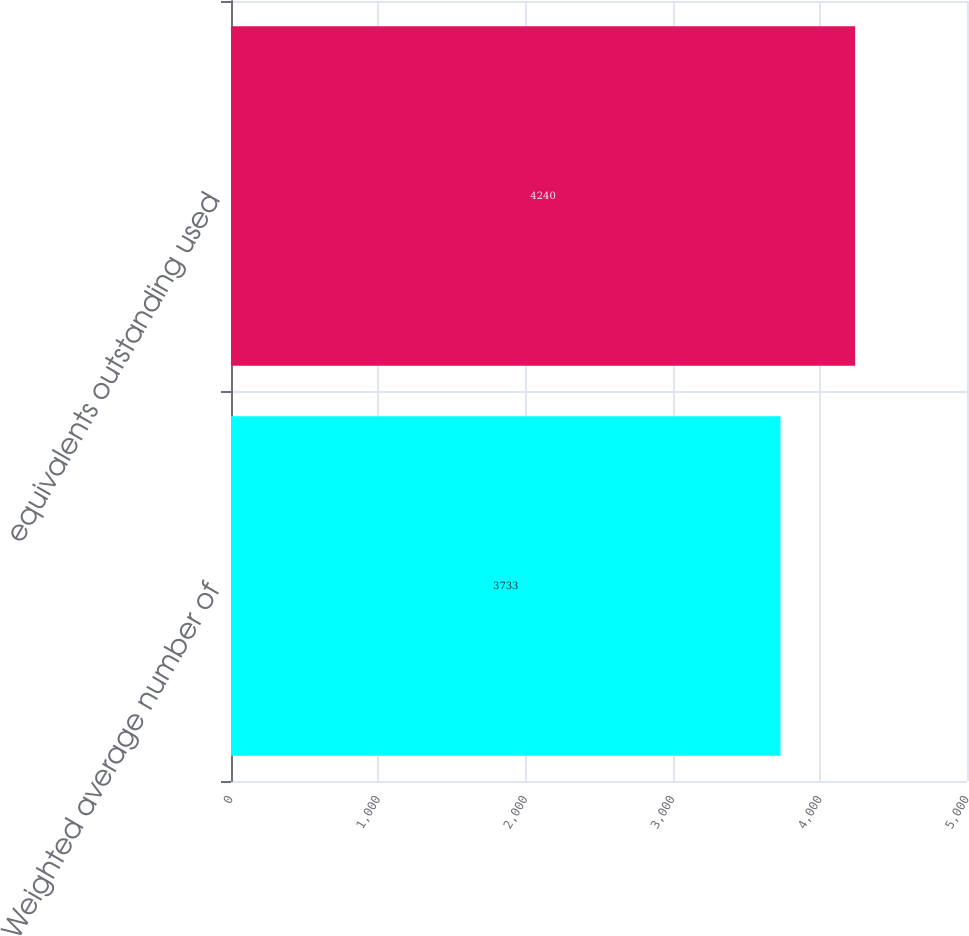Convert chart. <chart><loc_0><loc_0><loc_500><loc_500><bar_chart><fcel>Weighted average number of<fcel>equivalents outstanding used<nl><fcel>3733<fcel>4240<nl></chart> 